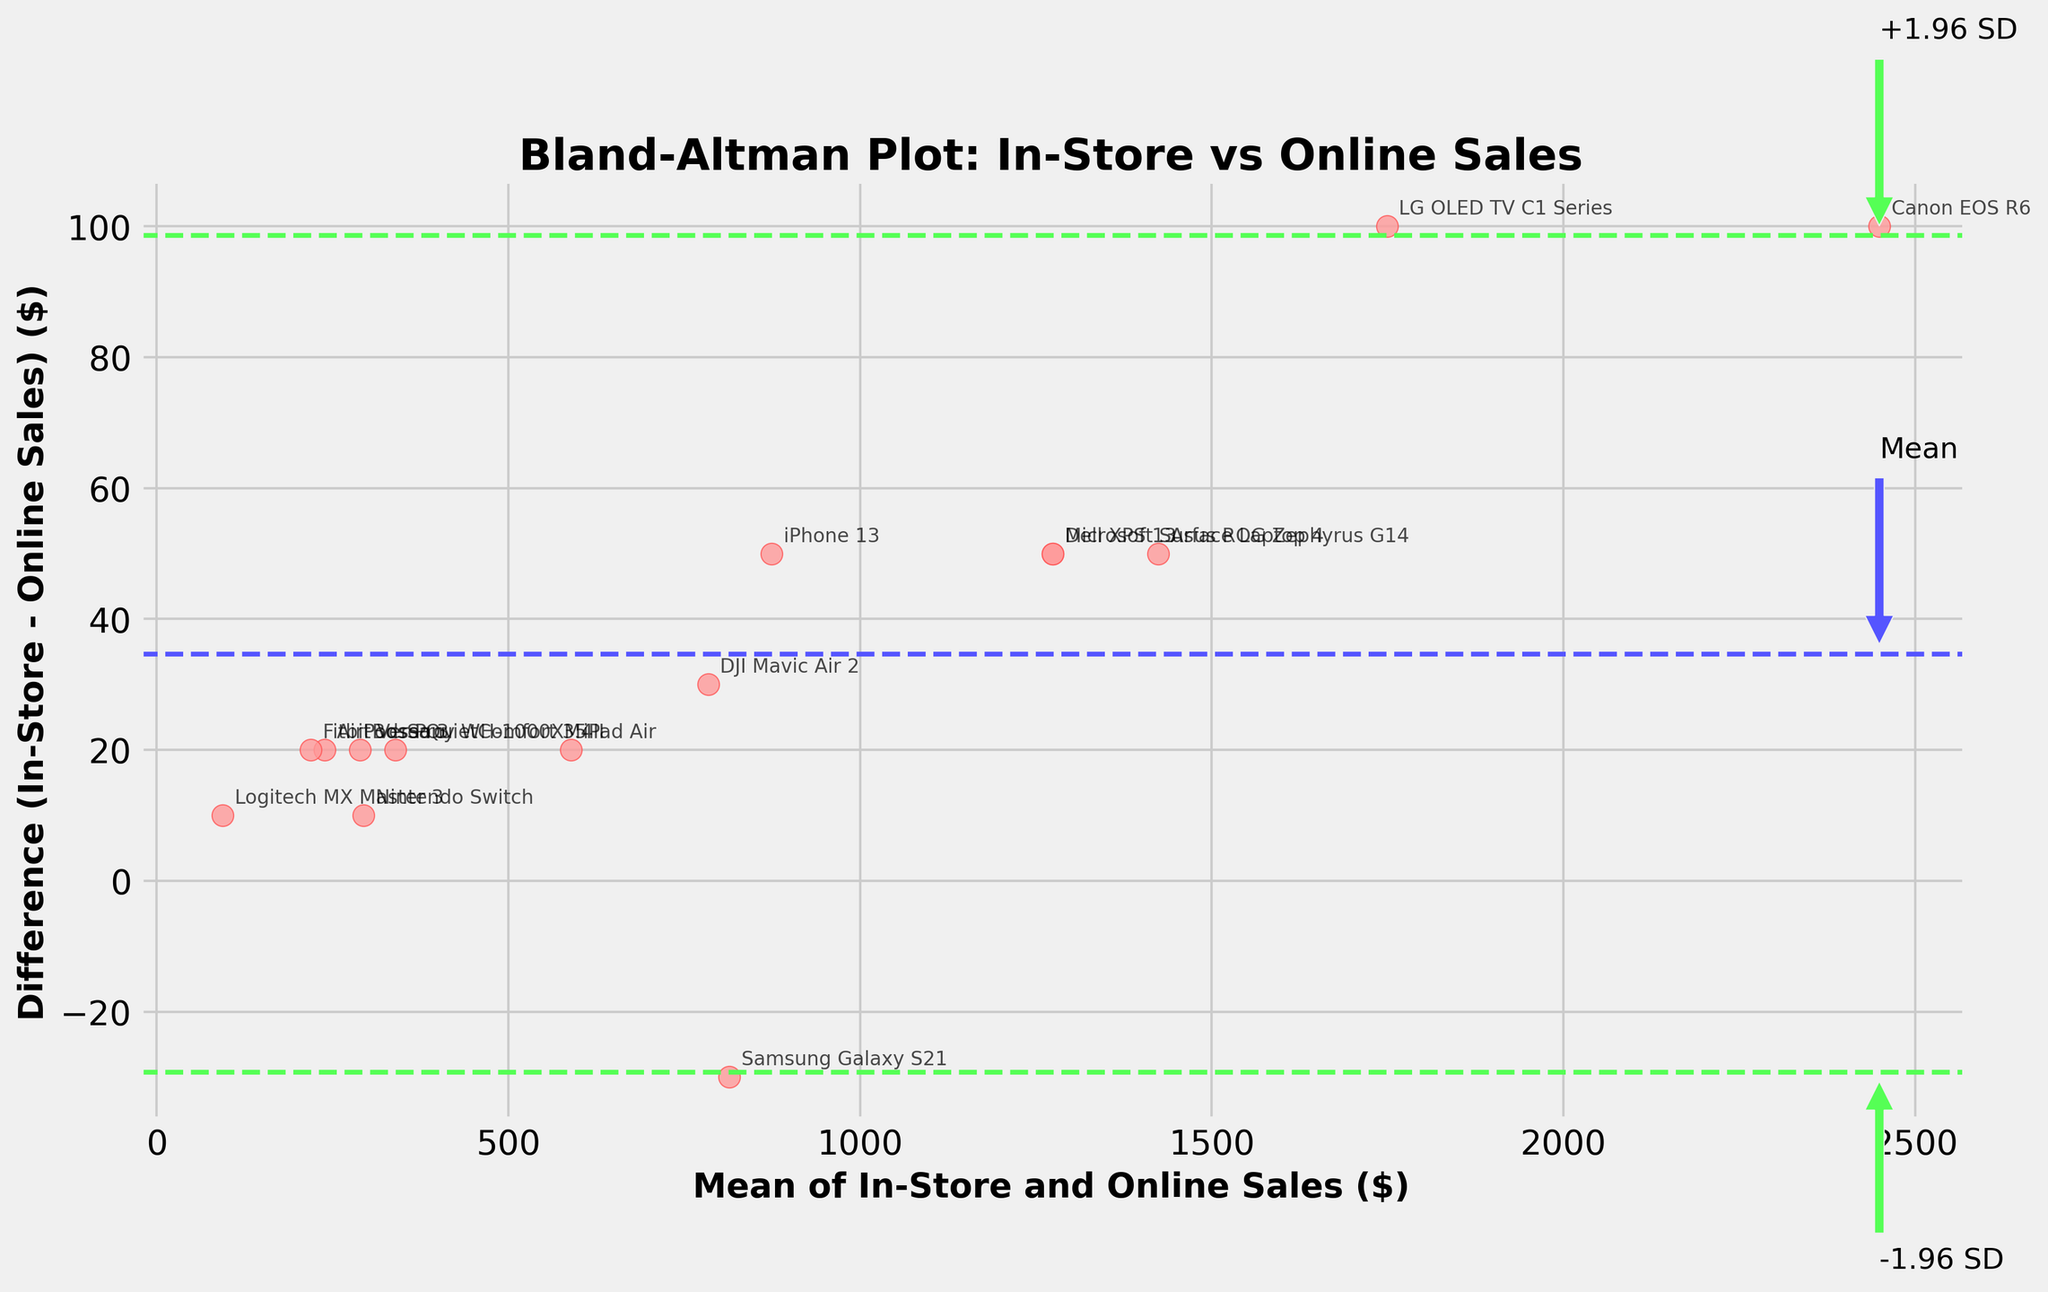How many data points are displayed on the plot? By counting all the individual points on the plot, each representing a tech product, we can determine the number of data points. There are 15 products in the data, so there are 15 points on the plot.
Answer: 15 What is the title of the plot? The title of the plot is located at the top of the figure and is usually used to describe what the plot is about. Here, the title clearly states "Bland-Altman Plot: In-Store vs Online Sales".
Answer: Bland-Altman Plot: In-Store vs Online Sales Which product has the largest positive difference between in-store and online sales? To find the product with the largest positive difference, look for the point that is farthest towards the top of the plot. The furthest point upwards indicates the product with the highest in-store sales compared to online sales. This point belongs to the Canon EOS R6.
Answer: Canon EOS R6 Which price range has most of its points below the mean difference line? Observing the distribution of the points in relation to the mean difference line, you would count the number of points below this line within each price range. Overall, most lower-priced items, particularly "200-299", are below this line.
Answer: 200-299 What does the solid horizontal line represent? The solid horizontal line across the plot is usually meant to show the mean difference between in-store and online sales. This allows us to see how much, on average, these two sales figures differ from each other.
Answer: Mean difference How does the mean difference line help in interpreting the plot? The mean difference line helps by providing a central reference point. Points above this line indicate that in-store sales are higher than online, and points below mean online sales are higher than in-store.
Answer: Central reference Which product appears to have approximately equal in-store and online sales? By finding the point closest to the mean difference of 0, we can identify the product with nearly equal sales figures in both in-store and online channels. The Samsung Galaxy S21 is closest to this line.
Answer: Samsung Galaxy S21 How is the variability between in-store and online sales illustrated in the plot? The variability is illustrated by the spread of the points around the mean difference line and the dashed lines representing ±1.96 standard deviations from the mean. Higher spread indicates more variability.
Answer: Spread around mean What does it mean if a point lies outside the ±1.96 SD lines? Points outside the ±1.96 SD lines represent outliers. These differences are unusually large, indicating significant discrepancies between in-store and online sales. Products like Canon EOS R6 fall into this category.
Answer: Outliers Which product represents an outlier with a significantly high in-store sales compared to online sales? By identifying the point that lies significantly above the upper ±1.96 SD line, we can spot an outlier. This outlier is the Canon EOS R6.
Answer: Canon EOS R6 